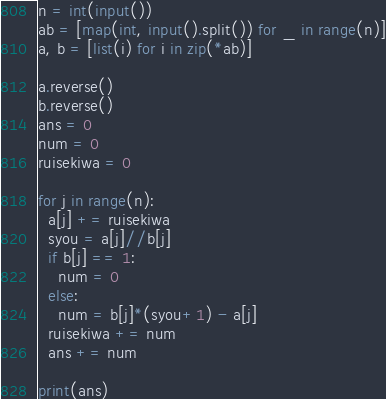Convert code to text. <code><loc_0><loc_0><loc_500><loc_500><_Python_>n = int(input())
ab = [map(int, input().split()) for _ in range(n)]
a, b = [list(i) for i in zip(*ab)]
 
a.reverse()
b.reverse()
ans = 0
num = 0
ruisekiwa = 0

for j in range(n):
  a[j] += ruisekiwa
  syou = a[j]//b[j]
  if b[j] == 1:
    num = 0
  else:
    num = b[j]*(syou+1) - a[j]
  ruisekiwa += num
  ans += num

print(ans)</code> 